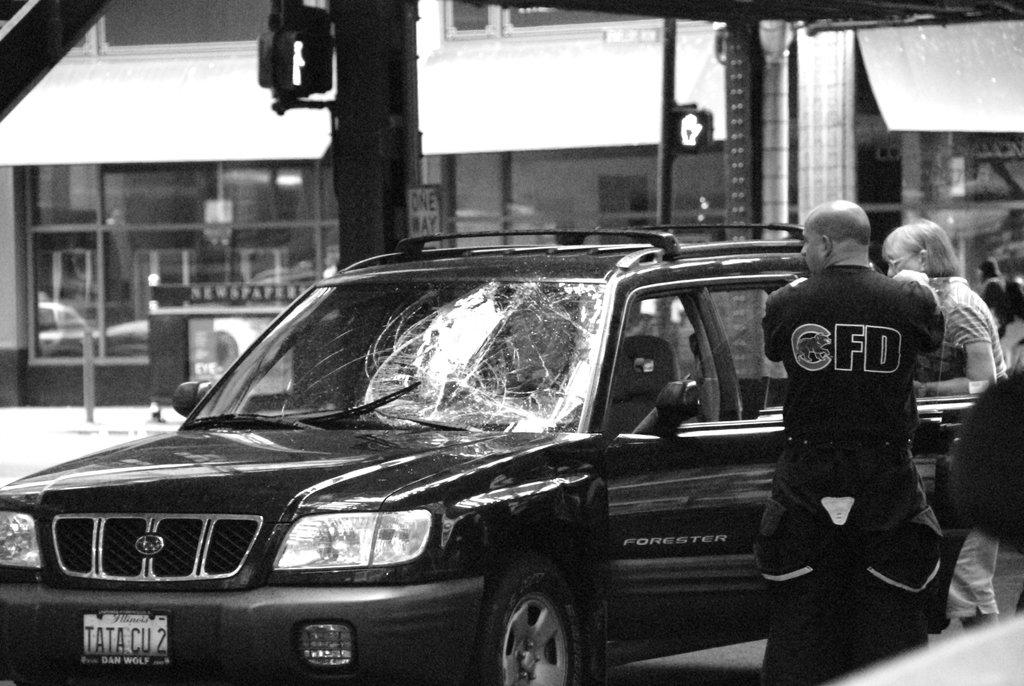What is the color scheme of the image? The image is black and white. What type of vehicle can be seen in the image? There is a car in the image. What type of structure is present in the image? There is a building in the image. What type of vertical structures are in the image? There are poles in the image. What type of flat surface with writing or images is in the image? There is a board in the image. What type of indicators are in the image? There are signals in the image. What type of transparent material is in the image? There is glass in the image. What type of general term for visible items can be used to describe the image? There are objects in the image. How many girls are visible in the image? There are no girls present in the image. What type of news can be seen on the board in the image? There is no news present on the board in the image; it is a black and white image with no text or images that suggest news. 